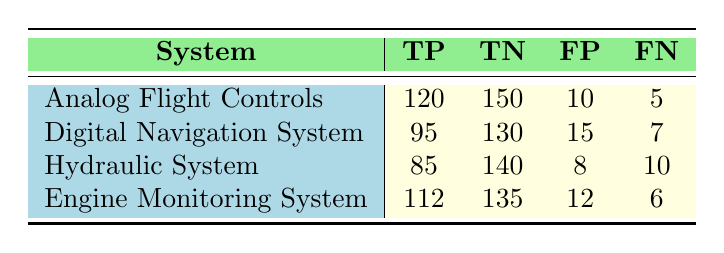What is the true positive count for the Hydraulic System? The true positive count for the Hydraulic System is directly given in the table under the TP column for that system. It shows a value of 85.
Answer: 85 What is the false negative count for the Digital Navigation System? The false negative count for the Digital Navigation System is found under the FN column specific to that system, which shows a value of 7.
Answer: 7 Which system has the highest number of true negatives? To determine which system has the highest number of true negatives, I compare the TN values across all systems. The Analog Flight Controls has the highest TN with a value of 150.
Answer: Analog Flight Controls What is the average true positive count across all systems? To find the average true positive count, I add the true positive counts of all systems (120 + 95 + 85 + 112 = 412) and divide by the number of systems (4). Hence, 412 divided by 4 equals 103.
Answer: 103 Is the false positive count for the Engine Monitoring System greater than the false negative count for the Hydraulic System? The false positive count for the Engine Monitoring System is 12, and the false negative count for the Hydraulic System is 10. Since 12 is greater than 10, the statement is true.
Answer: Yes Which system has the lowest count of false positives? To find the system with the lowest count of false positives, I look at the FP values for each system: 10, 15, 8, and 12. The Hydraulic System has the lowest FP count of 8.
Answer: Hydraulic System What is the total count of true positives and false negatives for the Analog Flight Controls? For the Analog Flight Controls, the true positive count is 120 and the false negative count is 5. Adding these values together (120 + 5) gives 125.
Answer: 125 If you combine true positives and false positives for the Digital Navigation System, what is the total? For the Digital Navigation System, the true positive count is 95 and the false positive count is 15. Adding these together (95 + 15) results in a total of 110.
Answer: 110 What is the difference between the true positive count of the Engine Monitoring System and the Hydraulic System? The true positive count for the Engine Monitoring System is 112, and for the Hydraulic System, it is 85. The difference is calculated by subtracting 85 from 112, which gives 27.
Answer: 27 